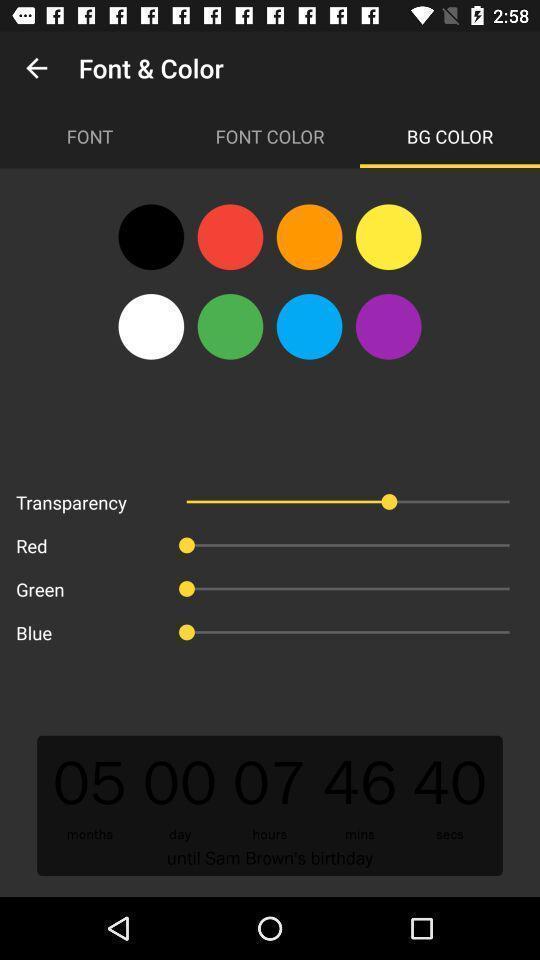Please provide a description for this image. Set of background colors. 